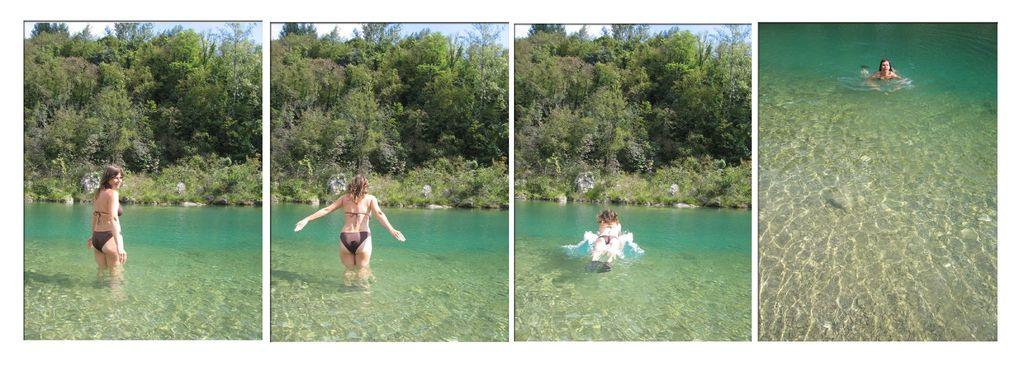Who is present in the image? There is a woman in the image. What is the woman doing in the image? The woman is standing in the water and swimming in the water. What can be seen in the background of the image? There are trees and the sky visible in the background of the image. What type of fruit is the woman holding in her hand while swimming in the image? There is no fruit present in the image, and the woman is not holding anything in her hand. 